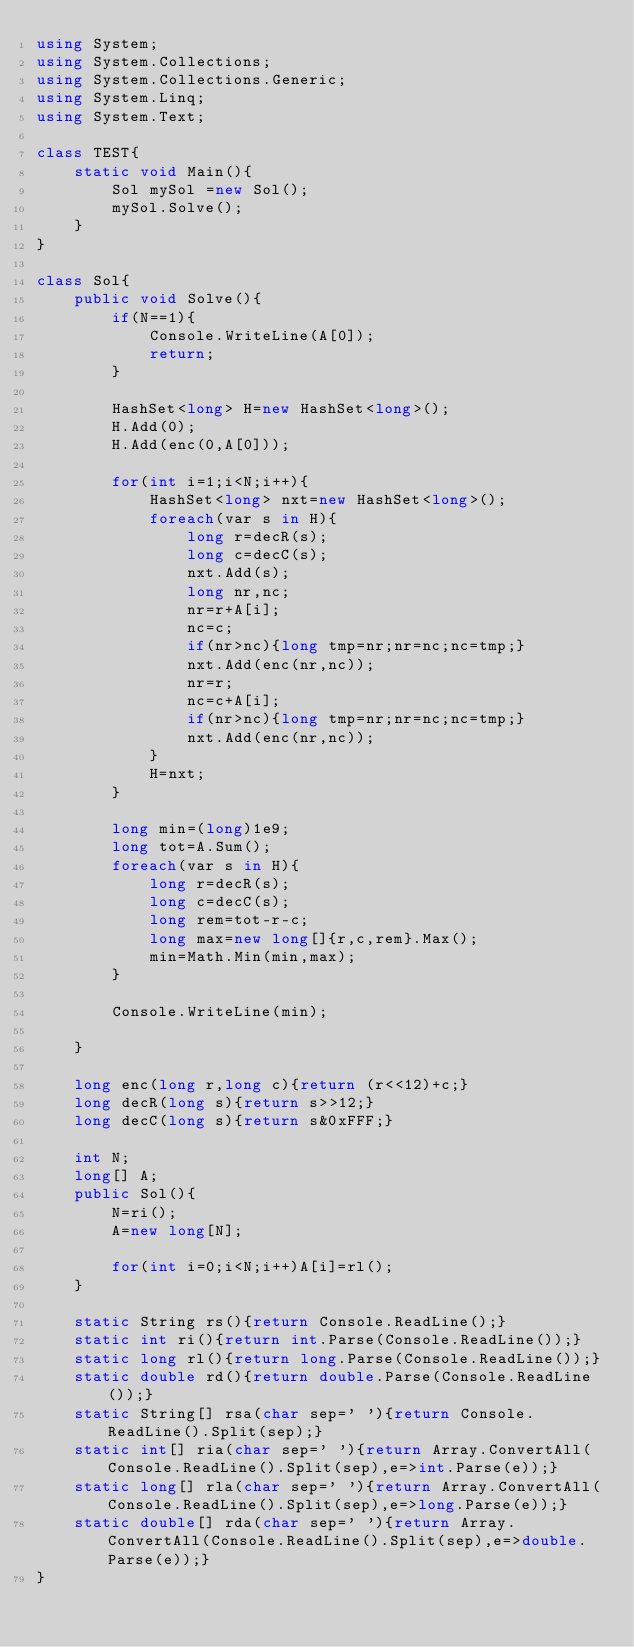<code> <loc_0><loc_0><loc_500><loc_500><_C#_>using System;
using System.Collections;
using System.Collections.Generic;
using System.Linq;
using System.Text;

class TEST{
	static void Main(){
		Sol mySol =new Sol();
		mySol.Solve();
	}
}

class Sol{
	public void Solve(){
		if(N==1){
			Console.WriteLine(A[0]);
			return;
		}
		
		HashSet<long> H=new HashSet<long>();
		H.Add(0);
		H.Add(enc(0,A[0]));
		
		for(int i=1;i<N;i++){
			HashSet<long> nxt=new HashSet<long>();
			foreach(var s in H){
				long r=decR(s);
				long c=decC(s);
				nxt.Add(s);
				long nr,nc;
				nr=r+A[i];
				nc=c;
				if(nr>nc){long tmp=nr;nr=nc;nc=tmp;}
				nxt.Add(enc(nr,nc));
				nr=r;
				nc=c+A[i];
				if(nr>nc){long tmp=nr;nr=nc;nc=tmp;}
				nxt.Add(enc(nr,nc));
			}
			H=nxt;
		}
		
		long min=(long)1e9;
		long tot=A.Sum();
		foreach(var s in H){
			long r=decR(s);
			long c=decC(s);
			long rem=tot-r-c;
			long max=new long[]{r,c,rem}.Max();
			min=Math.Min(min,max);
		}
		
		Console.WriteLine(min);
		
	}
	
	long enc(long r,long c){return (r<<12)+c;}
	long decR(long s){return s>>12;}
	long decC(long s){return s&0xFFF;}
	
	int N;
	long[] A;
	public Sol(){
		N=ri();
		A=new long[N];
		
		for(int i=0;i<N;i++)A[i]=rl();
	}

	static String rs(){return Console.ReadLine();}
	static int ri(){return int.Parse(Console.ReadLine());}
	static long rl(){return long.Parse(Console.ReadLine());}
	static double rd(){return double.Parse(Console.ReadLine());}
	static String[] rsa(char sep=' '){return Console.ReadLine().Split(sep);}
	static int[] ria(char sep=' '){return Array.ConvertAll(Console.ReadLine().Split(sep),e=>int.Parse(e));}
	static long[] rla(char sep=' '){return Array.ConvertAll(Console.ReadLine().Split(sep),e=>long.Parse(e));}
	static double[] rda(char sep=' '){return Array.ConvertAll(Console.ReadLine().Split(sep),e=>double.Parse(e));}
}</code> 